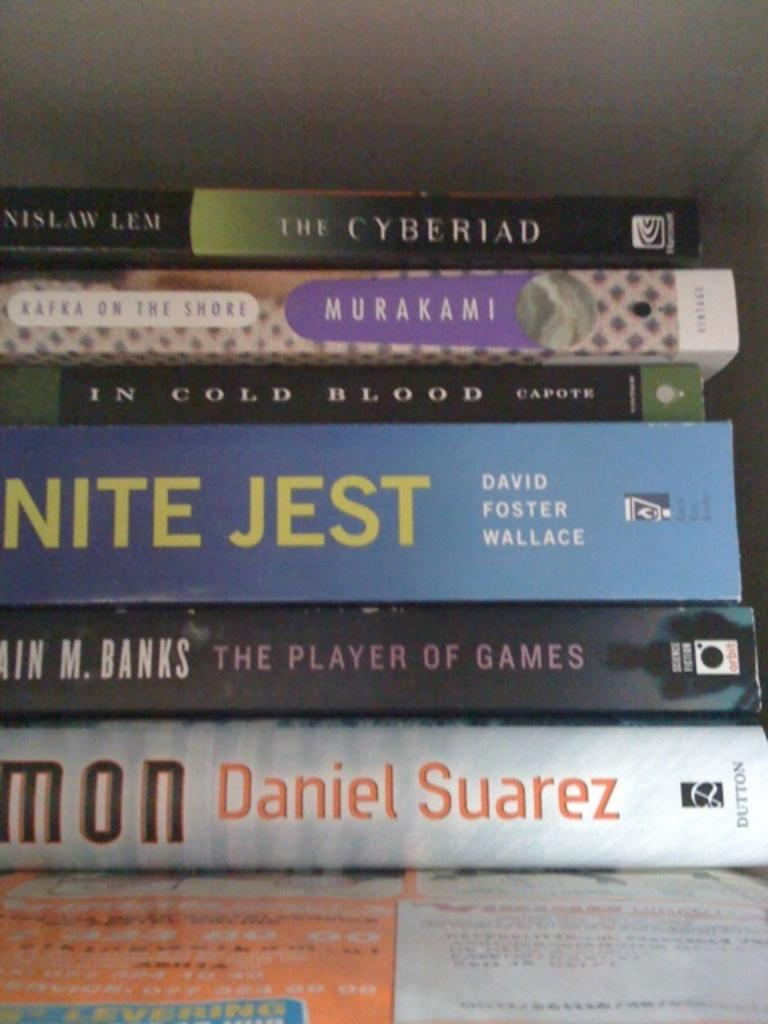<image>
Offer a succinct explanation of the picture presented. a stack of books with one of them by daniel suarez 